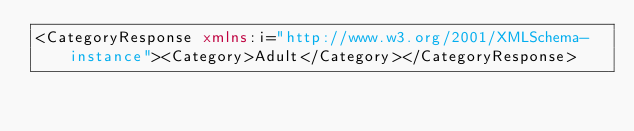<code> <loc_0><loc_0><loc_500><loc_500><_XML_><CategoryResponse xmlns:i="http://www.w3.org/2001/XMLSchema-instance"><Category>Adult</Category></CategoryResponse></code> 